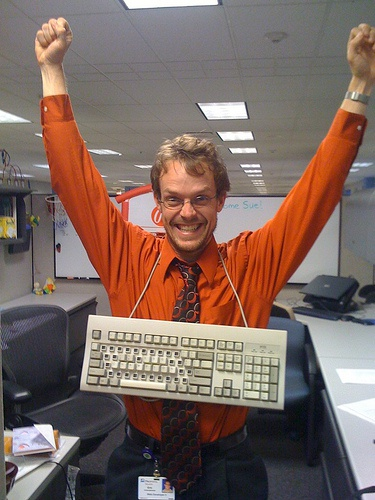Describe the objects in this image and their specific colors. I can see people in gray, red, black, brown, and maroon tones, keyboard in gray, darkgray, and beige tones, chair in gray and black tones, tie in gray, black, maroon, and brown tones, and chair in gray, black, and blue tones in this image. 